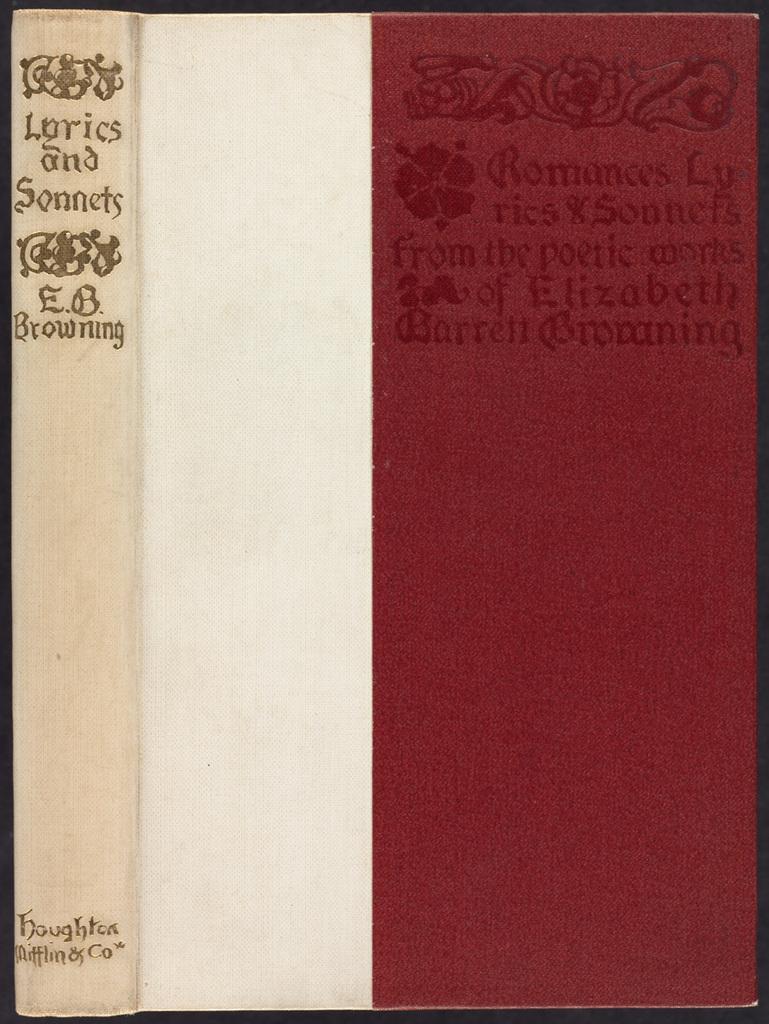Who is the author?
Your answer should be compact. E.b. browning. 